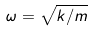Convert formula to latex. <formula><loc_0><loc_0><loc_500><loc_500>\omega = \sqrt { k / m }</formula> 